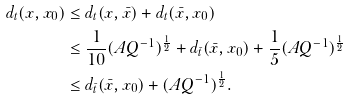Convert formula to latex. <formula><loc_0><loc_0><loc_500><loc_500>d _ { t } ( x , x _ { 0 } ) & \leq d _ { t } ( x , \bar { x } ) + d _ { t } ( \bar { x } , x _ { 0 } ) \\ & \leq \frac { 1 } { 1 0 } ( A Q ^ { - 1 } ) ^ { \frac { 1 } { 2 } } + d _ { \bar { t } } ( \bar { x } , x _ { 0 } ) + \frac { 1 } { 5 } ( A Q ^ { - 1 } ) ^ { \frac { 1 } { 2 } } \\ & \leq d _ { \bar { t } } ( \bar { x } , x _ { 0 } ) + ( A Q ^ { - 1 } ) ^ { \frac { 1 } { 2 } } .</formula> 